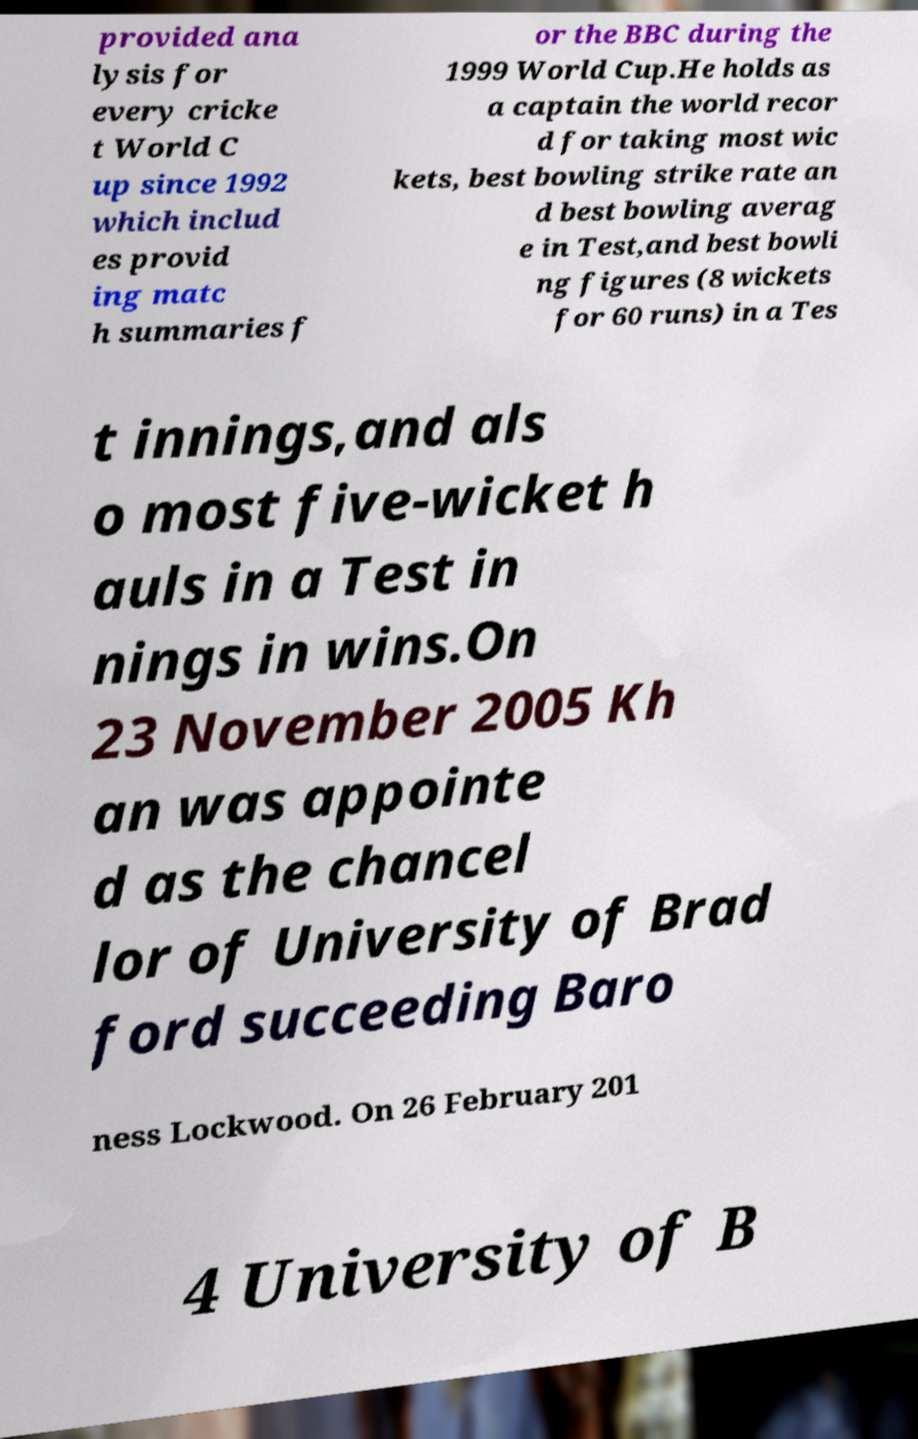There's text embedded in this image that I need extracted. Can you transcribe it verbatim? provided ana lysis for every cricke t World C up since 1992 which includ es provid ing matc h summaries f or the BBC during the 1999 World Cup.He holds as a captain the world recor d for taking most wic kets, best bowling strike rate an d best bowling averag e in Test,and best bowli ng figures (8 wickets for 60 runs) in a Tes t innings,and als o most five-wicket h auls in a Test in nings in wins.On 23 November 2005 Kh an was appointe d as the chancel lor of University of Brad ford succeeding Baro ness Lockwood. On 26 February 201 4 University of B 